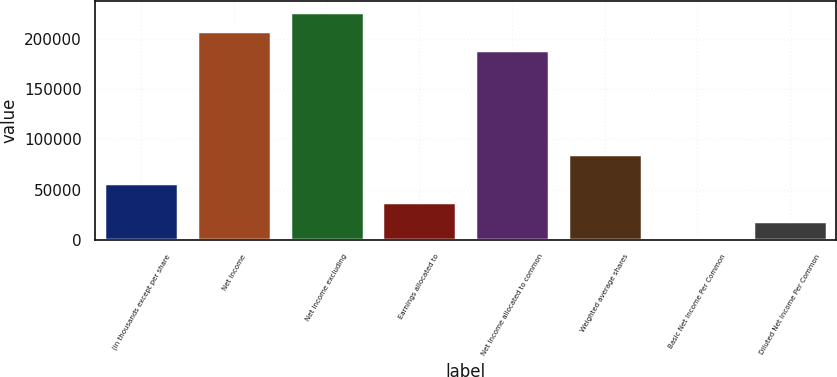Convert chart. <chart><loc_0><loc_0><loc_500><loc_500><bar_chart><fcel>(in thousands except per share<fcel>Net Income<fcel>Net Income excluding<fcel>Earnings allocated to<fcel>Net Income allocated to common<fcel>Weighted average shares<fcel>Basic Net Income Per Common<fcel>Diluted Net Income Per Common<nl><fcel>56915.8<fcel>207363<fcel>226334<fcel>37944.6<fcel>188392<fcel>85406<fcel>2.21<fcel>18973.4<nl></chart> 